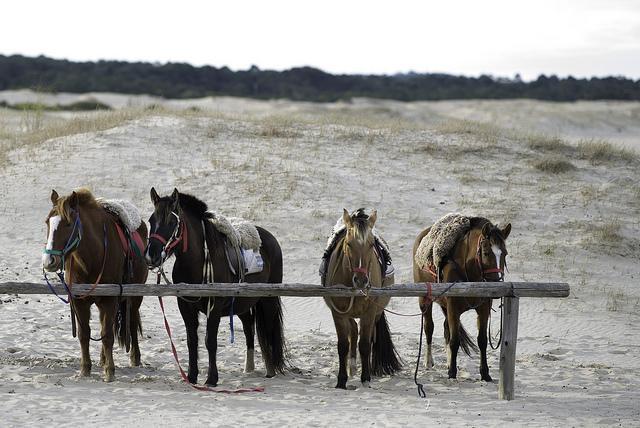How many horses are there?
Give a very brief answer. 4. How many horses can you see?
Give a very brief answer. 4. How many people are walking?
Give a very brief answer. 0. 